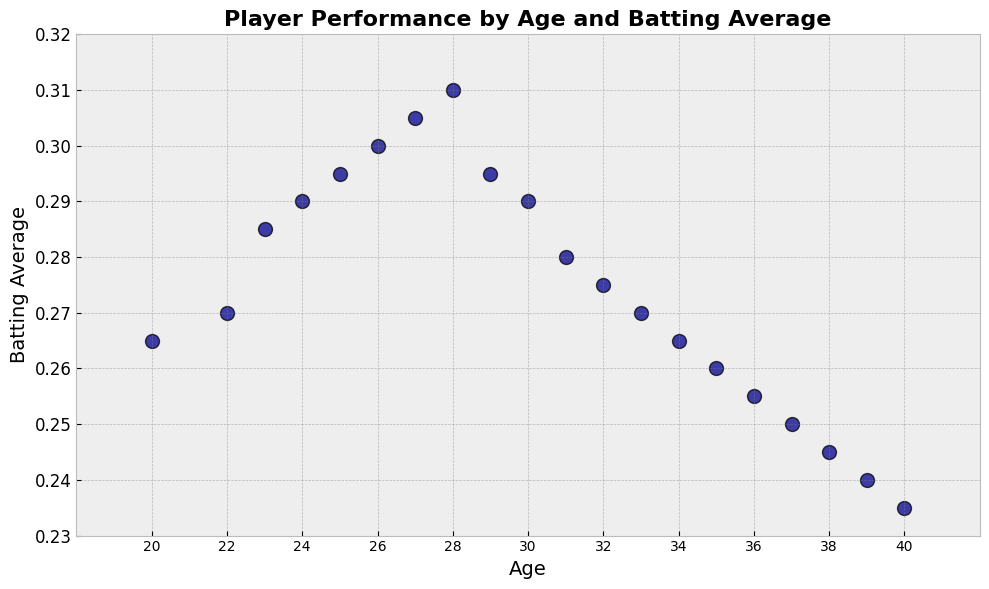What is the batting average of players aged 29? To find the batting average of players aged 29, refer to the figure where age 29 intersects with the batting average axis.
Answer: 0.295 What's the general trend of batting averages as age increases from 20 to 40? Look at the scatter plot points from age 20 to 40. Notice if the batting average values generally increase or decrease with age.
Answer: Decrease For which ages is the batting average the highest? Identify the peak points in the scatter plot, showing the highest values on the y-axis, and note the corresponding x-axis ages.
Answer: 27 and 28 How does the batting average of a 24-year-old compare to that of a 30-year-old? Compare the scatter plot points for ages 24 and 30, noting their respective batting average values.
Answer: Higher What's the average batting average between ages 25 and 30? Identify the batting average values for ages 25 to 30, add them up and divide by the number of these data points.
Answer: 0.295 At which age does the batting average start to consistently decrease? Examine the trend in the scatter plot points and locate the age where the batting average begins to consistently drop.
Answer: 28 What's the difference in batting average between the youngest and oldest players? Identify the batting averages at age 20 and age 40, then subtract the older player's average from the younger's.
Answer: 0.03 Between which pair of ages does the largest decrease in batting average occur? Scan the scatter plot to spot the two adjacent points with the steepest downward slope.
Answer: 28 and 29 What is the batting average for ages in the early thirties, 30 to 35? Refer to the scatter plot to find the batting averages for ages 30 through 35.
Answer: 0.285 How does the plot style help in interpreting the data? The plot style uses clear markers and grid lines which make it easier to follow trends and identify specific data points.
Answer: Clear markers and grid lines 